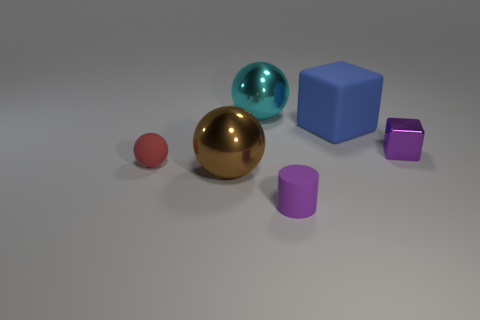Are there any other things that have the same shape as the purple matte object?
Your answer should be compact. No. There is a thing that is the same color as the small metallic cube; what is its shape?
Your response must be concise. Cylinder. There is a cube that is the same material as the big cyan ball; what size is it?
Offer a very short reply. Small. Is the shiny block the same color as the tiny cylinder?
Provide a succinct answer. Yes. Are the small red sphere and the tiny purple object in front of the tiny red object made of the same material?
Give a very brief answer. Yes. Is there anything else that has the same color as the matte ball?
Ensure brevity in your answer.  No. What number of objects are either purple objects in front of the small block or metallic balls that are behind the red object?
Make the answer very short. 2. What shape is the object that is on the right side of the brown metal ball and in front of the red rubber thing?
Make the answer very short. Cylinder. There is a big shiny thing to the right of the brown object; what number of spheres are to the left of it?
Your response must be concise. 2. How many objects are tiny purple things that are on the left side of the blue cube or cyan objects?
Your answer should be compact. 2. 